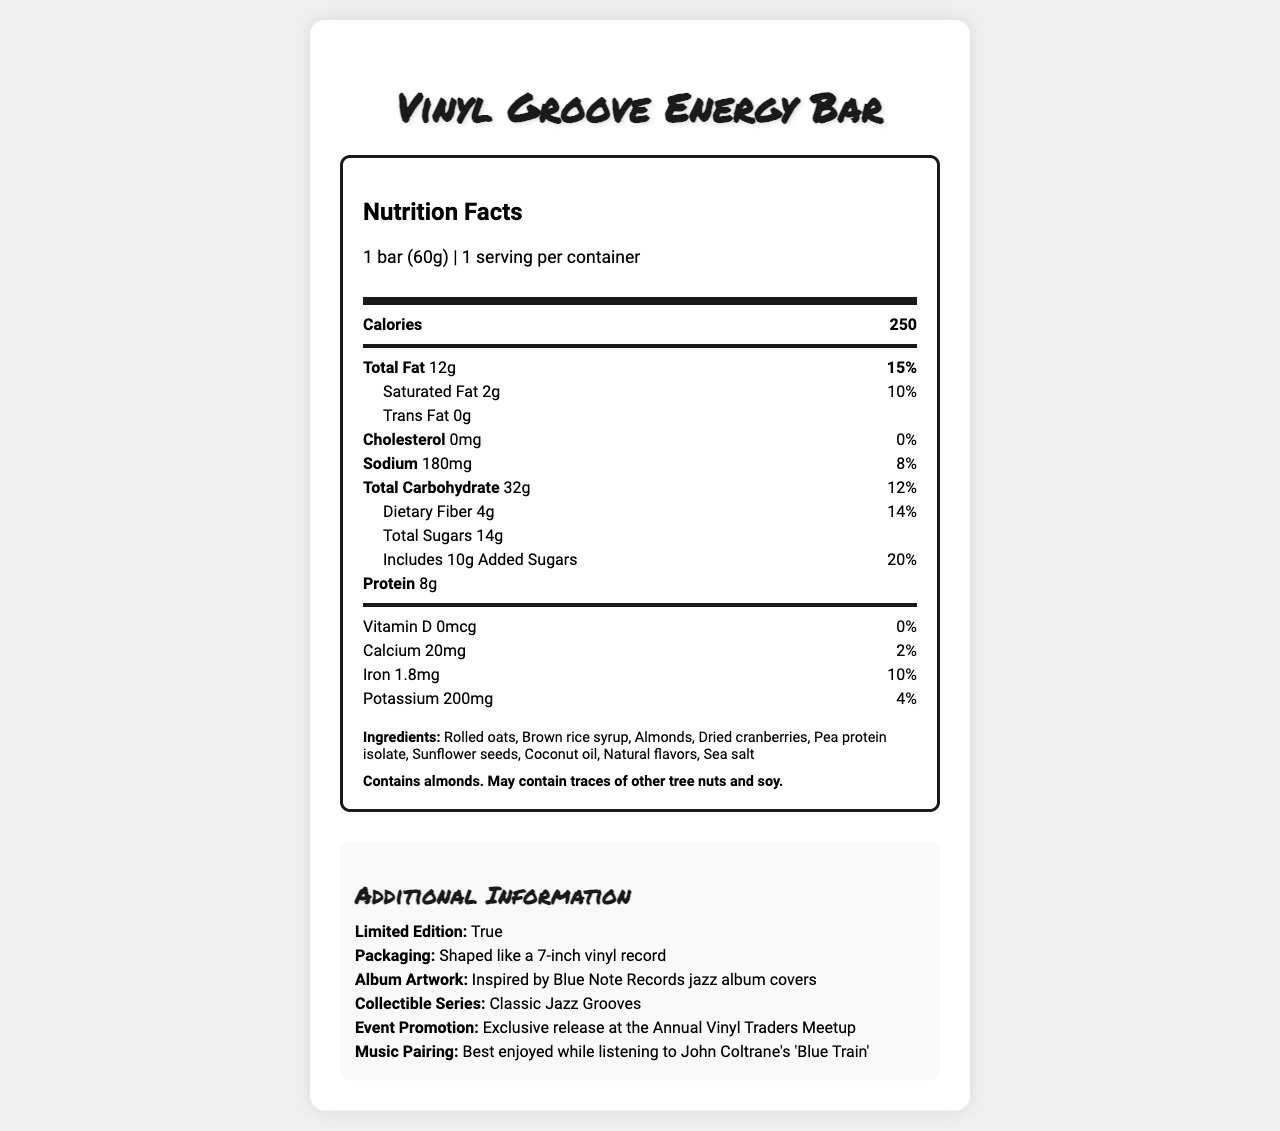what is the serving size of the Vinyl Groove Energy Bar? The serving size is explicitly mentioned in the document's Nutrition Facts Label under the serving size section.
Answer: 1 bar (60g) how many calories are in one serving of the Vinyl Groove Energy Bar? The number of calories per serving is listed at the top of the Nutrition Facts section.
Answer: 250 what is the total fat content in one Vinyl Groove Energy Bar? The total fat content is specified in the Nutrition Facts under the Total Fat section.
Answer: 12g how much protein does one Vinyl Groove Energy Bar contain? The protein content is listed in the Nutrition Facts under the protein section.
Answer: 8g what are the main ingredients in the Vinyl Groove Energy Bar? The ingredients are listed in the ingredients section of the document.
Answer: Rolled oats, Brown rice syrup, Almonds, Dried cranberries, Pea protein isolate, Sunflower seeds, Coconut oil, Natural flavors, Sea salt which of the following is a primary ingredient of the Vinyl Groove Energy Bar? A. Chocolate B. Almonds C. Raisins D. Honey Almonds is listed as one of the main ingredients while chocolate, raisins, and honey are not mentioned in the ingredients list.
Answer: B how much added sugar is in the Vinyl Groove Energy Bar? The amount of added sugars is specified in the Nutrition Facts Label under the "Includes Added Sugars" section.
Answer: 10g is the Vinyl Groove Energy Bar gluten-free? The document does not provide information regarding whether the product is gluten-free.
Answer: Not enough information does the Vinyl Groove Energy Bar contain any allergens? The allergen information section indicates that the bar contains almonds and may contain traces of other tree nuts and soy.
Answer: Yes is there any cholesterol in the Vinyl Groove Energy Bar? The Nutrition Facts Label shows that there is 0mg of cholesterol in the Vinyl Groove Energy Bar.
Answer: No which of the following vitamins and minerals are present in the Vinyl Groove Energy Bar? I. Vitamin D II. Calcium III. Iron IV. Potassium Calcium, Iron, and Potassium are listed in the Nutrition Facts, but Vitamin D is mentioned as 0mcg.
Answer: II, III, IV what is the best music pairing for enjoying the Vinyl Groove Energy Bar according to the document? The additional information section suggests that the bar is best enjoyed while listening to John Coltrane's 'Blue Train'.
Answer: John Coltrane's 'Blue Train' is the Vinyl Groove Energy Bar a limited edition product? The additional information section explicitly states that the product is limited edition.
Answer: Yes describe the main features of the Vinyl Groove Energy Bar and its packaging. The description provides an overview of the key features found in the additional information and nutrition sections, including the unique packaging and event promotion, along with the nutritional content and ingredient details.
Answer: The Vinyl Groove Energy Bar is a vinyl-shaped energy bar with album artwork packaging inspired by Blue Note Records jazz album covers. It is a limited edition product, part of the "Classic Jazz Grooves" collectible series, and is promoted for exclusive release at the Annual Vinyl Traders Meetup. The bar contains 250 calories per 60g serving with ingredients including rolled oats, almonds, and dried cranberries, providing 8g of protein and 12g of total fat. what percentage of the daily value of dietary fiber does one Vinyl Groove Energy Bar provide? The Nutrition Facts Label lists that the dietary fiber content is 4g, which is 14% of the daily value.
Answer: 14% how many servings are there per container of the Vinyl Groove Energy Bar? The serving size section at the top of the Nutrition Facts Label indicates that there is 1 serving per container.
Answer: 1 